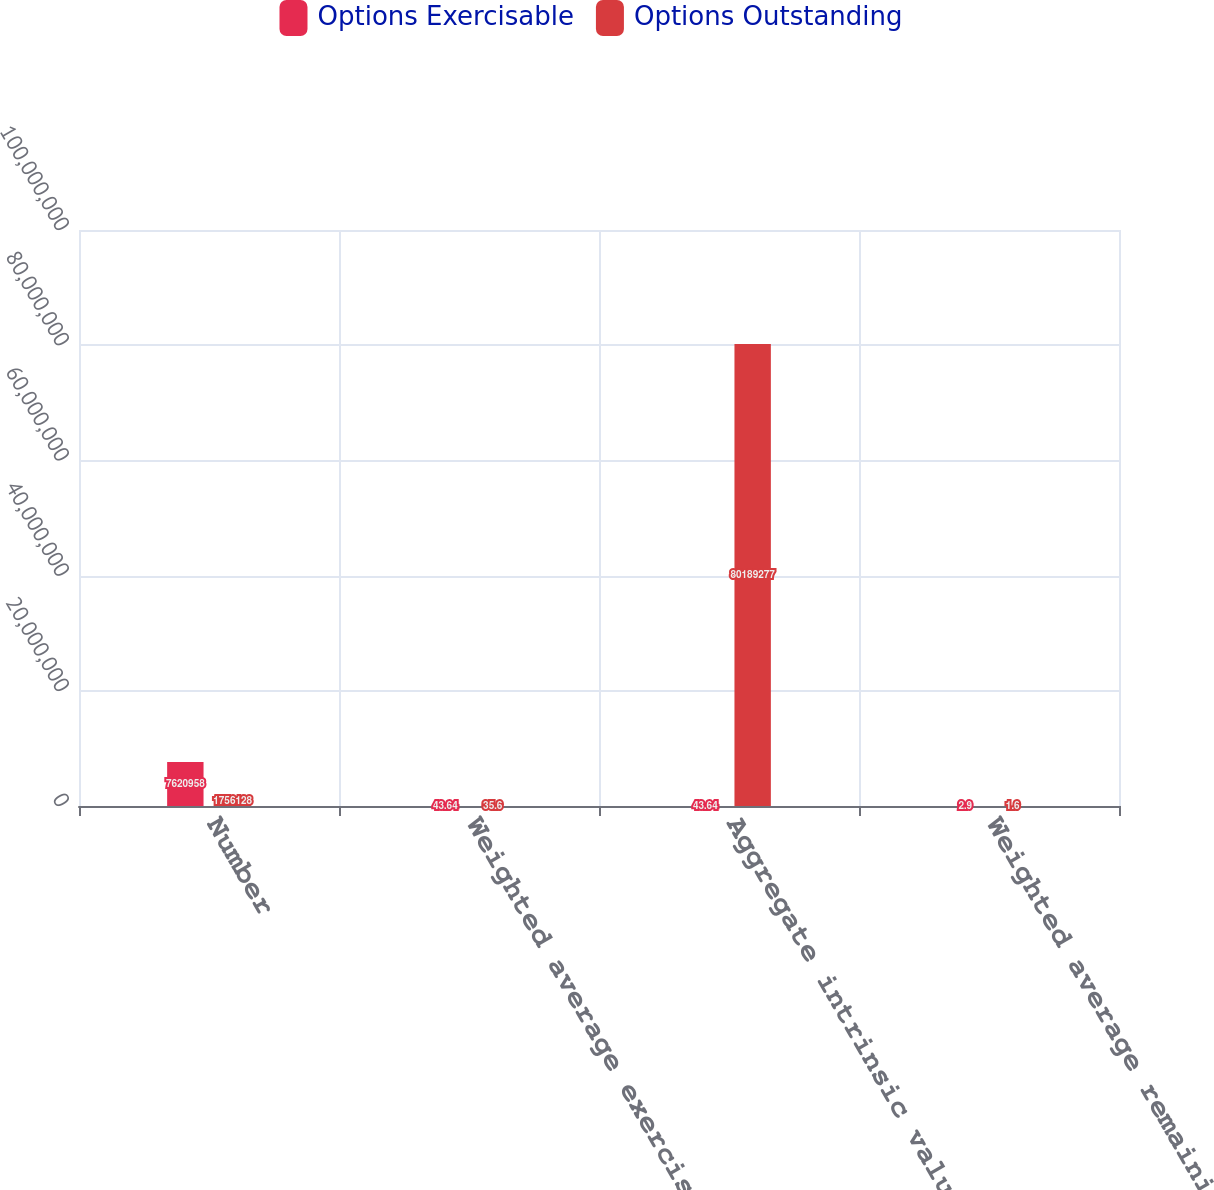Convert chart to OTSL. <chart><loc_0><loc_0><loc_500><loc_500><stacked_bar_chart><ecel><fcel>Number<fcel>Weighted average exercise<fcel>Aggregate intrinsic value as<fcel>Weighted average remaining<nl><fcel>Options Exercisable<fcel>7.62096e+06<fcel>43.64<fcel>43.64<fcel>2.9<nl><fcel>Options Outstanding<fcel>1.75613e+06<fcel>35.6<fcel>8.01893e+07<fcel>1.6<nl></chart> 